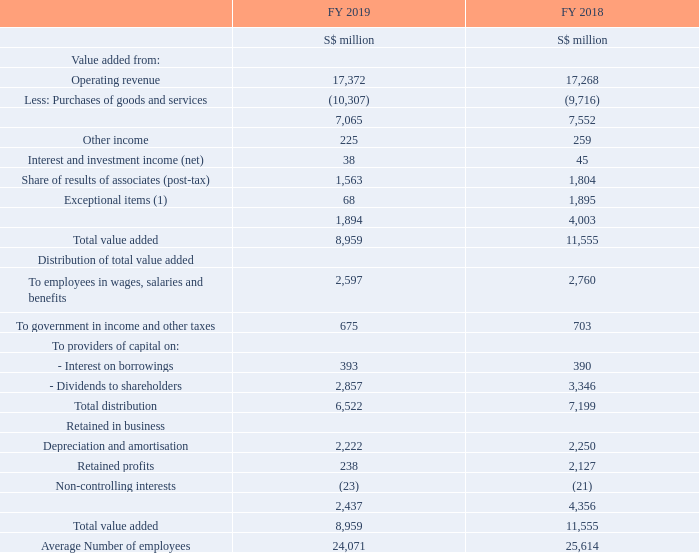Group Value Added Statements
Note:
(1) FY 2018 included the gain on disposal of economic interest in NetLink Trust of S$2.03 billion.
What was included in the exceptional items in FY2018? Fy 2018 included the gain on disposal of economic interest in netlink trust of s$2.03 billion. What was the value of retained profits in FY 2018?
Answer scale should be: million. 2,127. What are the 2 components for providers of capital? Interest on borrowings, dividends to shareholders. Which year was there a higher average number of employees? 25,614 > 24,071
Answer: 2018. Which year had a higher total value added figure? 11,555 > 8,959
Answer: 2018. How many components are there under the section "retained in business"? Depreciation and amortisation##Retained profits##Non-controlling interests
Answer: 3. 